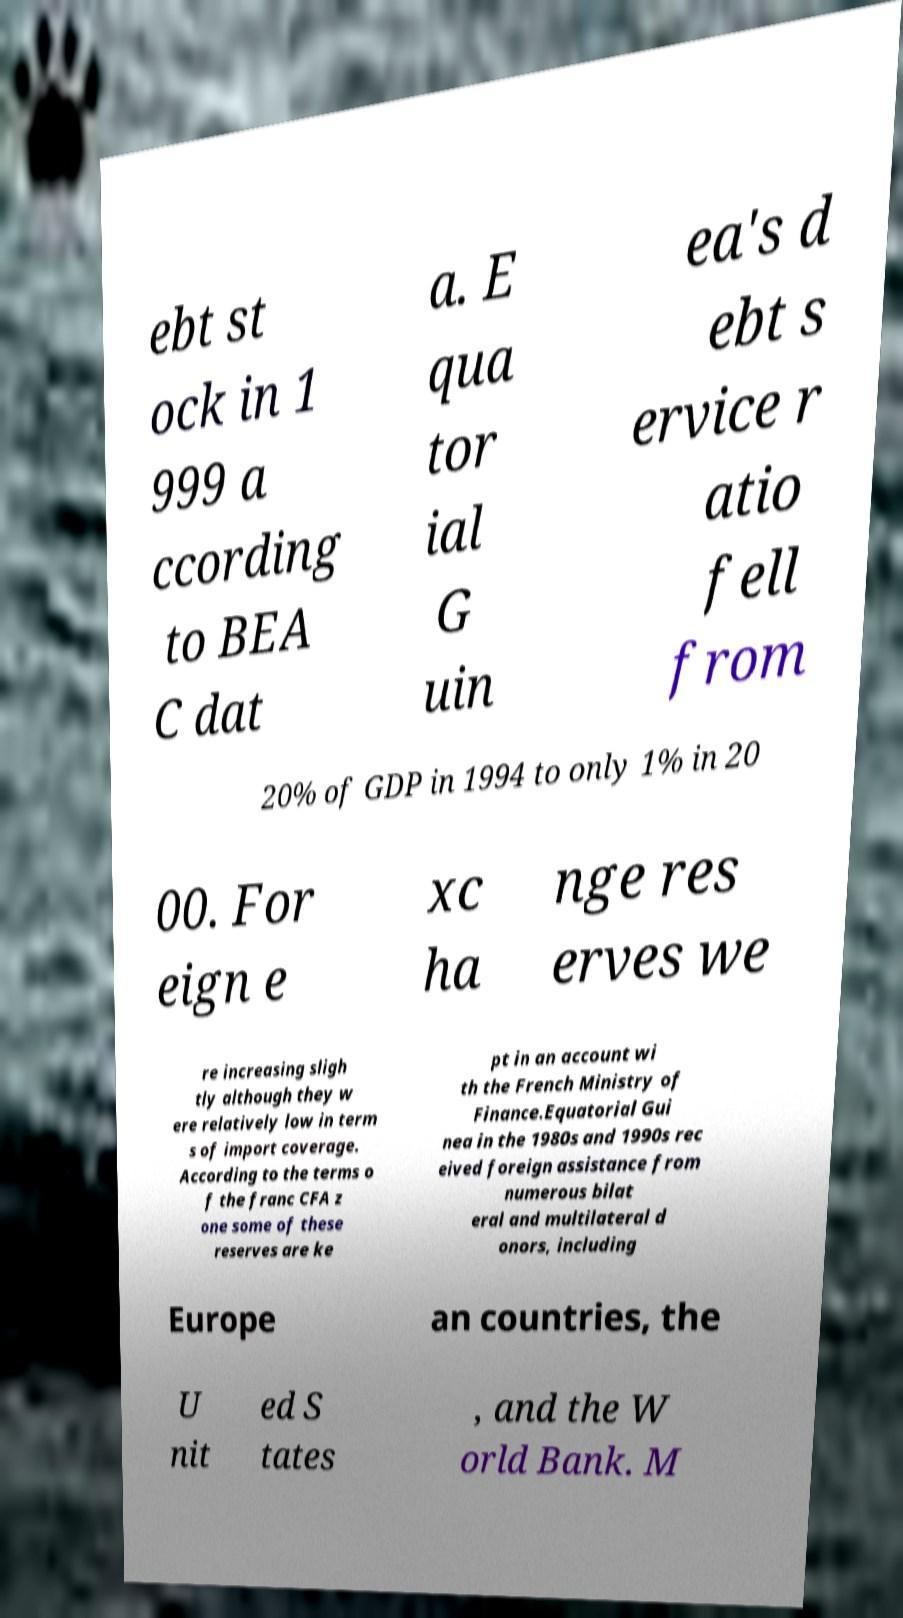What messages or text are displayed in this image? I need them in a readable, typed format. ebt st ock in 1 999 a ccording to BEA C dat a. E qua tor ial G uin ea's d ebt s ervice r atio fell from 20% of GDP in 1994 to only 1% in 20 00. For eign e xc ha nge res erves we re increasing sligh tly although they w ere relatively low in term s of import coverage. According to the terms o f the franc CFA z one some of these reserves are ke pt in an account wi th the French Ministry of Finance.Equatorial Gui nea in the 1980s and 1990s rec eived foreign assistance from numerous bilat eral and multilateral d onors, including Europe an countries, the U nit ed S tates , and the W orld Bank. M 